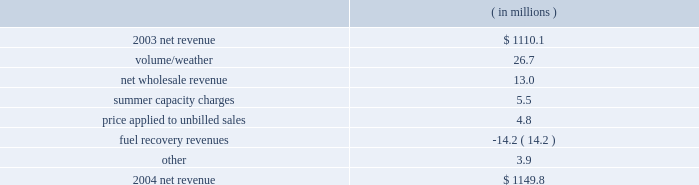Entergy gulf states , inc .
Management's financial discussion and analysis .
The volume/weather variance resulted primarily from an increase of 1179 gwh in electricity usage in the industrial sector .
Billed usage also increased a total of 291 gwh in the residential , commercial , and governmental sectors .
The increase in net wholesale revenue is primarily due to an increase in sales volume to municipal and co-op customers .
Summer capacity charges variance is due to the amortization in 2003 of deferred capacity charges for the summer of 2001 compared to the absence of the amortization in 2004 .
The amortization of these capacity charges began in june 2002 and ended in may 2003 .
The price applied to unbilled sales variance resulted primarily from an increase in the fuel price applied to unbilled sales .
Fuel recovery revenues represent an under-recovery of fuel charges that are recovered in base rates .
Entergy gulf states recorded $ 22.6 million of provisions in 2004 for potential rate refunds .
These provisions are not included in the net revenue table above because they are more than offset by provisions recorded in 2003 .
Gross operating revenues , fuel and purchased power expenses , and other regulatory credits gross operating revenues increased primarily due to an increase of $ 187.8 million in fuel cost recovery revenues as a result of higher fuel rates in both the louisiana and texas jurisdictions .
The increases in volume/weather and wholesale revenue , discussed above , also contributed to the increase .
Fuel and purchased power expenses increased primarily due to : 2022 increased recovery of deferred fuel costs due to higher fuel rates ; 2022 increases in the market prices of natural gas , coal , and purchased power ; and 2022 an increase in electricity usage , discussed above .
Other regulatory credits increased primarily due to the amortization in 2003 of deferred capacity charges for the summer of 2001 compared to the absence of amortization in 2004 .
The amortization of these charges began in june 2002 and ended in may 2003 .
2003 compared to 2002 net revenue , which is entergy gulf states' measure of gross margin , consists of operating revenues net of : 1 ) fuel , fuel-related , and purchased power expenses and 2 ) other regulatory credits .
Following is an analysis of the change in net revenue comparing 2003 to 2002. .
What portion of the net change in net revenue during 2004 is due to the change in volume/weather for entergy gulf states , inc? 
Computations: (26.7 / (1149.8 - 1110.1))
Answer: 0.67254. Entergy gulf states , inc .
Management's financial discussion and analysis .
The volume/weather variance resulted primarily from an increase of 1179 gwh in electricity usage in the industrial sector .
Billed usage also increased a total of 291 gwh in the residential , commercial , and governmental sectors .
The increase in net wholesale revenue is primarily due to an increase in sales volume to municipal and co-op customers .
Summer capacity charges variance is due to the amortization in 2003 of deferred capacity charges for the summer of 2001 compared to the absence of the amortization in 2004 .
The amortization of these capacity charges began in june 2002 and ended in may 2003 .
The price applied to unbilled sales variance resulted primarily from an increase in the fuel price applied to unbilled sales .
Fuel recovery revenues represent an under-recovery of fuel charges that are recovered in base rates .
Entergy gulf states recorded $ 22.6 million of provisions in 2004 for potential rate refunds .
These provisions are not included in the net revenue table above because they are more than offset by provisions recorded in 2003 .
Gross operating revenues , fuel and purchased power expenses , and other regulatory credits gross operating revenues increased primarily due to an increase of $ 187.8 million in fuel cost recovery revenues as a result of higher fuel rates in both the louisiana and texas jurisdictions .
The increases in volume/weather and wholesale revenue , discussed above , also contributed to the increase .
Fuel and purchased power expenses increased primarily due to : 2022 increased recovery of deferred fuel costs due to higher fuel rates ; 2022 increases in the market prices of natural gas , coal , and purchased power ; and 2022 an increase in electricity usage , discussed above .
Other regulatory credits increased primarily due to the amortization in 2003 of deferred capacity charges for the summer of 2001 compared to the absence of amortization in 2004 .
The amortization of these charges began in june 2002 and ended in may 2003 .
2003 compared to 2002 net revenue , which is entergy gulf states' measure of gross margin , consists of operating revenues net of : 1 ) fuel , fuel-related , and purchased power expenses and 2 ) other regulatory credits .
Following is an analysis of the change in net revenue comparing 2003 to 2002. .
What are the provisions for potential rate refunds as a percentage of net revenue in 2004? 
Computations: (22.6 / 1149.8)
Answer: 0.01966. Entergy gulf states , inc .
Management's financial discussion and analysis .
The volume/weather variance resulted primarily from an increase of 1179 gwh in electricity usage in the industrial sector .
Billed usage also increased a total of 291 gwh in the residential , commercial , and governmental sectors .
The increase in net wholesale revenue is primarily due to an increase in sales volume to municipal and co-op customers .
Summer capacity charges variance is due to the amortization in 2003 of deferred capacity charges for the summer of 2001 compared to the absence of the amortization in 2004 .
The amortization of these capacity charges began in june 2002 and ended in may 2003 .
The price applied to unbilled sales variance resulted primarily from an increase in the fuel price applied to unbilled sales .
Fuel recovery revenues represent an under-recovery of fuel charges that are recovered in base rates .
Entergy gulf states recorded $ 22.6 million of provisions in 2004 for potential rate refunds .
These provisions are not included in the net revenue table above because they are more than offset by provisions recorded in 2003 .
Gross operating revenues , fuel and purchased power expenses , and other regulatory credits gross operating revenues increased primarily due to an increase of $ 187.8 million in fuel cost recovery revenues as a result of higher fuel rates in both the louisiana and texas jurisdictions .
The increases in volume/weather and wholesale revenue , discussed above , also contributed to the increase .
Fuel and purchased power expenses increased primarily due to : 2022 increased recovery of deferred fuel costs due to higher fuel rates ; 2022 increases in the market prices of natural gas , coal , and purchased power ; and 2022 an increase in electricity usage , discussed above .
Other regulatory credits increased primarily due to the amortization in 2003 of deferred capacity charges for the summer of 2001 compared to the absence of amortization in 2004 .
The amortization of these charges began in june 2002 and ended in may 2003 .
2003 compared to 2002 net revenue , which is entergy gulf states' measure of gross margin , consists of operating revenues net of : 1 ) fuel , fuel-related , and purchased power expenses and 2 ) other regulatory credits .
Following is an analysis of the change in net revenue comparing 2003 to 2002. .
What is the growth rate in net revenue in 2004 for entergy gulf states , inc? 
Computations: ((1149.8 - 1110.1) / 1110.1)
Answer: 0.03576. 